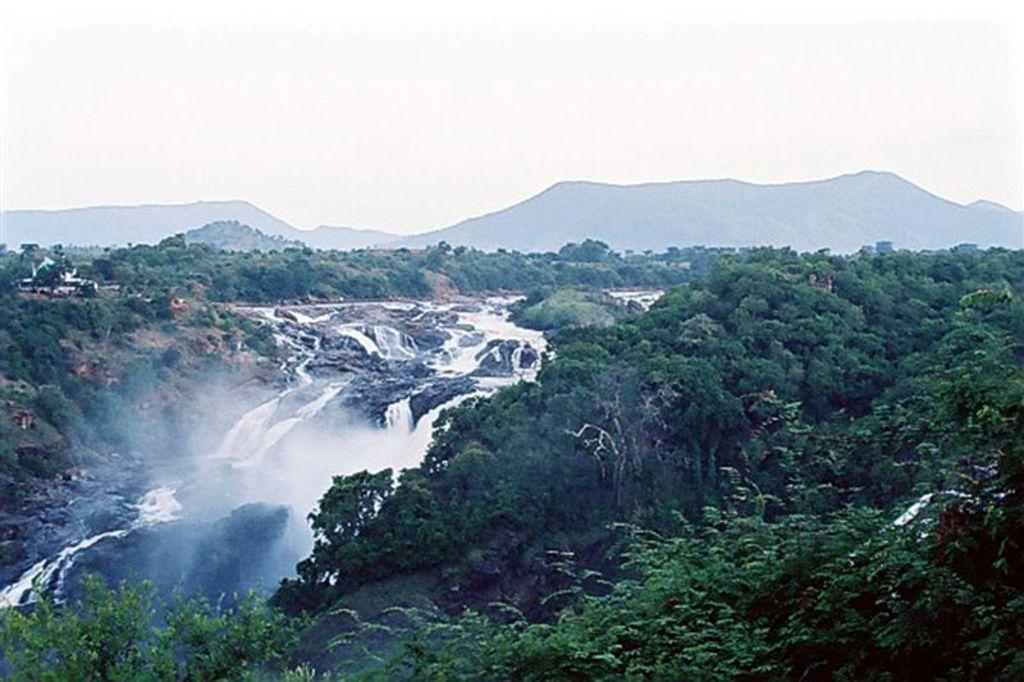Describe this image in one or two sentences. In this image, I can see trees, hills and a waterfall. In the background there is the sky. 